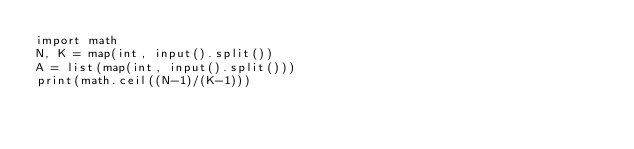Convert code to text. <code><loc_0><loc_0><loc_500><loc_500><_Python_>import math
N, K = map(int, input().split())
A = list(map(int, input().split()))
print(math.ceil((N-1)/(K-1)))
</code> 